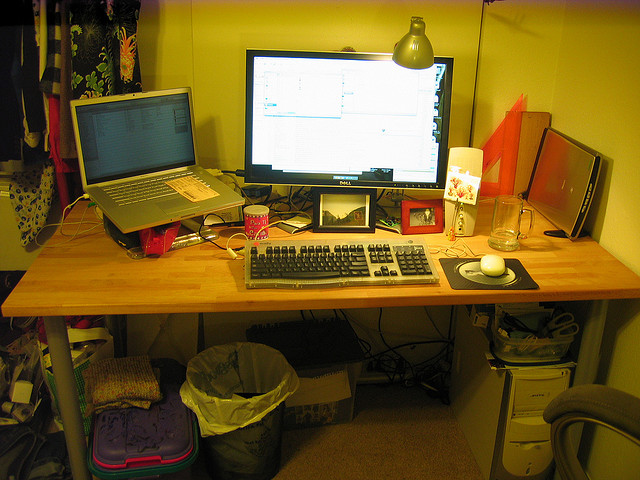<image>What setting is shown on the screen of the laptop? I don't know what settings are shown on the laptop screen. It could be windows, browser, media player or work. What setting is shown on the screen of the laptop? I am not sure what setting is shown on the screen of the laptop. It can be seen as 'backdrop', 'browser', 'dim', 'not sure', 'media player', 'open', 'work', 'windows', or 'brightness'. 